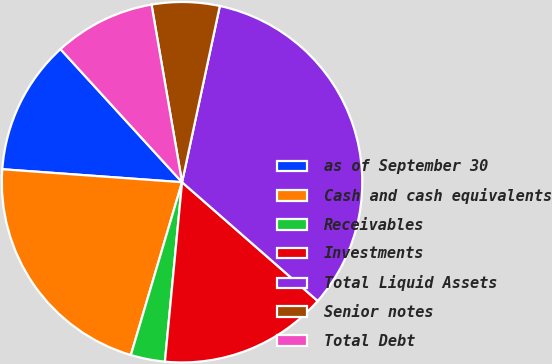Convert chart to OTSL. <chart><loc_0><loc_0><loc_500><loc_500><pie_chart><fcel>as of September 30<fcel>Cash and cash equivalents<fcel>Receivables<fcel>Investments<fcel>Total Liquid Assets<fcel>Senior notes<fcel>Total Debt<nl><fcel>12.07%<fcel>21.56%<fcel>3.07%<fcel>15.07%<fcel>33.08%<fcel>6.07%<fcel>9.07%<nl></chart> 